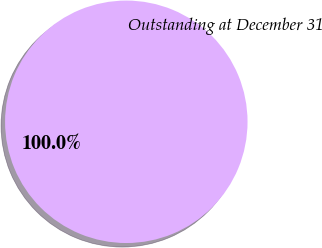<chart> <loc_0><loc_0><loc_500><loc_500><pie_chart><fcel>Outstanding at December 31<nl><fcel>100.0%<nl></chart> 